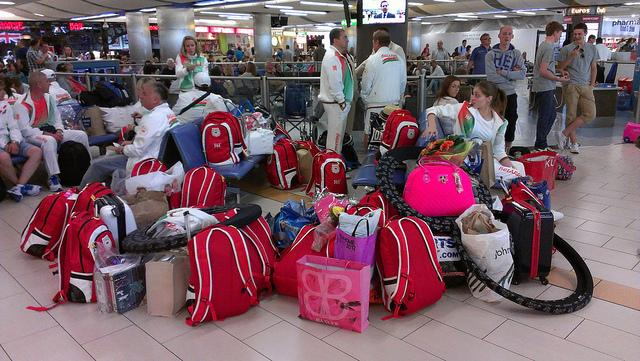Where is this scene taking place? Please explain your reasoning. airport. Luggage is piled up in a large building with people all around. airports are large places with lots of people and luggage. 